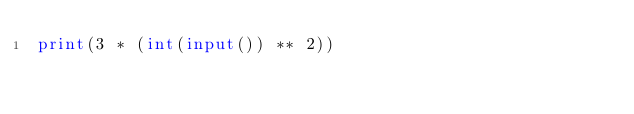Convert code to text. <code><loc_0><loc_0><loc_500><loc_500><_Python_>print(3 * (int(input()) ** 2))
</code> 